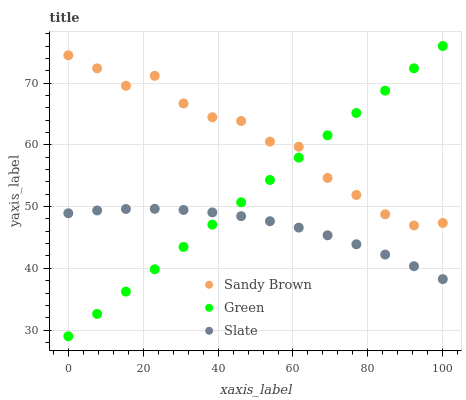Does Slate have the minimum area under the curve?
Answer yes or no. Yes. Does Sandy Brown have the maximum area under the curve?
Answer yes or no. Yes. Does Sandy Brown have the minimum area under the curve?
Answer yes or no. No. Does Slate have the maximum area under the curve?
Answer yes or no. No. Is Green the smoothest?
Answer yes or no. Yes. Is Sandy Brown the roughest?
Answer yes or no. Yes. Is Slate the smoothest?
Answer yes or no. No. Is Slate the roughest?
Answer yes or no. No. Does Green have the lowest value?
Answer yes or no. Yes. Does Slate have the lowest value?
Answer yes or no. No. Does Green have the highest value?
Answer yes or no. Yes. Does Sandy Brown have the highest value?
Answer yes or no. No. Is Slate less than Sandy Brown?
Answer yes or no. Yes. Is Sandy Brown greater than Slate?
Answer yes or no. Yes. Does Green intersect Sandy Brown?
Answer yes or no. Yes. Is Green less than Sandy Brown?
Answer yes or no. No. Is Green greater than Sandy Brown?
Answer yes or no. No. Does Slate intersect Sandy Brown?
Answer yes or no. No. 